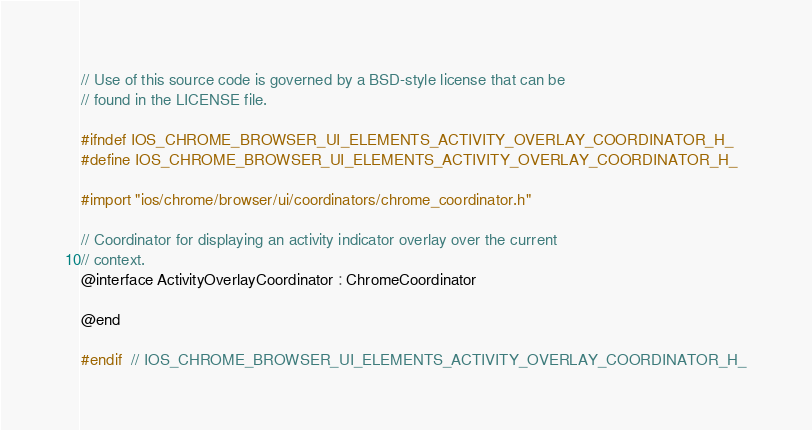Convert code to text. <code><loc_0><loc_0><loc_500><loc_500><_C_>// Use of this source code is governed by a BSD-style license that can be
// found in the LICENSE file.

#ifndef IOS_CHROME_BROWSER_UI_ELEMENTS_ACTIVITY_OVERLAY_COORDINATOR_H_
#define IOS_CHROME_BROWSER_UI_ELEMENTS_ACTIVITY_OVERLAY_COORDINATOR_H_

#import "ios/chrome/browser/ui/coordinators/chrome_coordinator.h"

// Coordinator for displaying an activity indicator overlay over the current
// context.
@interface ActivityOverlayCoordinator : ChromeCoordinator

@end

#endif  // IOS_CHROME_BROWSER_UI_ELEMENTS_ACTIVITY_OVERLAY_COORDINATOR_H_
</code> 